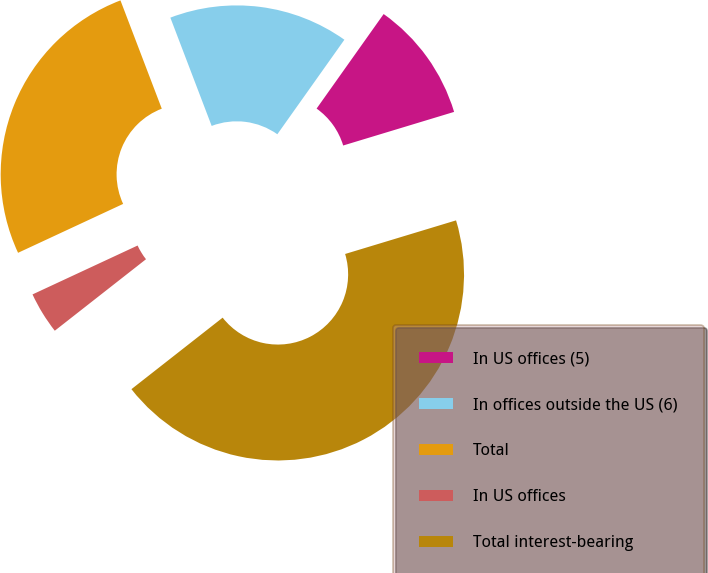Convert chart to OTSL. <chart><loc_0><loc_0><loc_500><loc_500><pie_chart><fcel>In US offices (5)<fcel>In offices outside the US (6)<fcel>Total<fcel>In US offices<fcel>Total interest-bearing<nl><fcel>10.5%<fcel>15.62%<fcel>26.13%<fcel>3.65%<fcel>44.1%<nl></chart> 